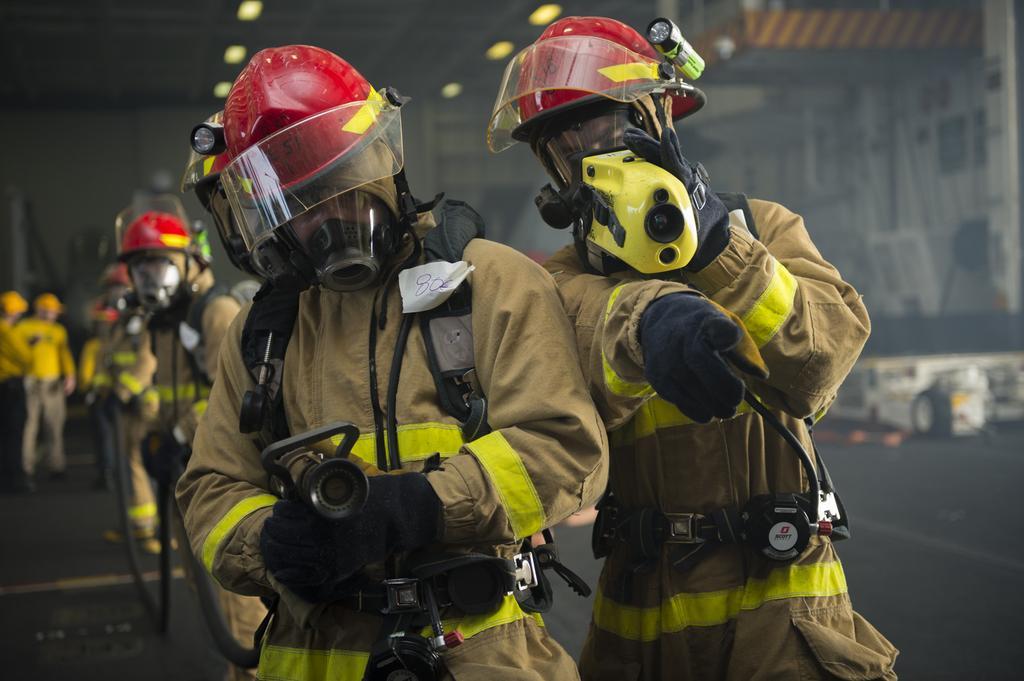In one or two sentences, can you explain what this image depicts? In this picture i can see many fireman's who are wearing the same dress and holding the water pipe. On the left background i can see some peoples wearing yellow t-shirt and they are standing near to the pipe. At the top there are lights. On the right i can see some posters on the wall. 